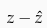<formula> <loc_0><loc_0><loc_500><loc_500>z - \hat { z }</formula> 